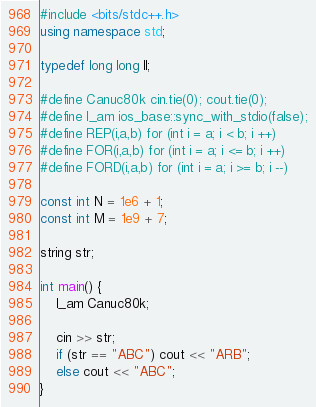Convert code to text. <code><loc_0><loc_0><loc_500><loc_500><_C++_>#include <bits/stdc++.h>
using namespace std;

typedef long long ll;

#define Canuc80k cin.tie(0); cout.tie(0);
#define I_am ios_base::sync_with_stdio(false);
#define REP(i,a,b) for (int i = a; i < b; i ++)
#define FOR(i,a,b) for (int i = a; i <= b; i ++)
#define FORD(i,a,b) for (int i = a; i >= b; i --)

const int N = 1e6 + 1;
const int M = 1e9 + 7;

string str;

int main() {
    I_am Canuc80k;

    cin >> str;
    if (str == "ABC") cout << "ARB";
    else cout << "ABC";
}</code> 